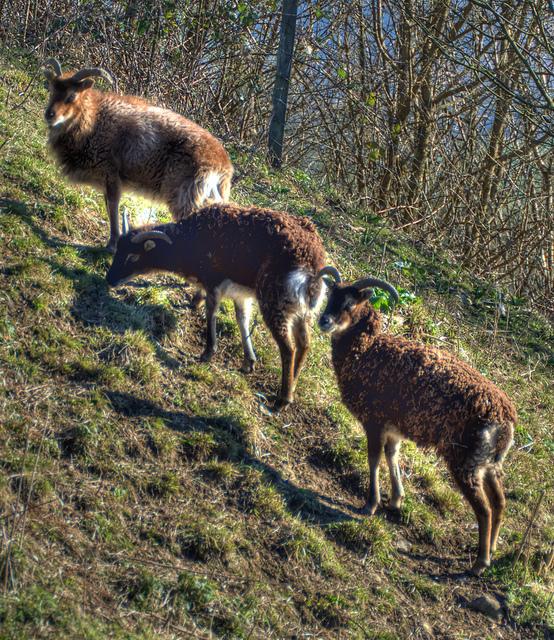Do this animals have tails?
Concise answer only. Yes. What are the goats climbing?
Quick response, please. Hill. How many goats do you see?
Answer briefly. 3. 